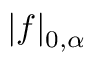<formula> <loc_0><loc_0><loc_500><loc_500>| f | _ { 0 , \alpha }</formula> 